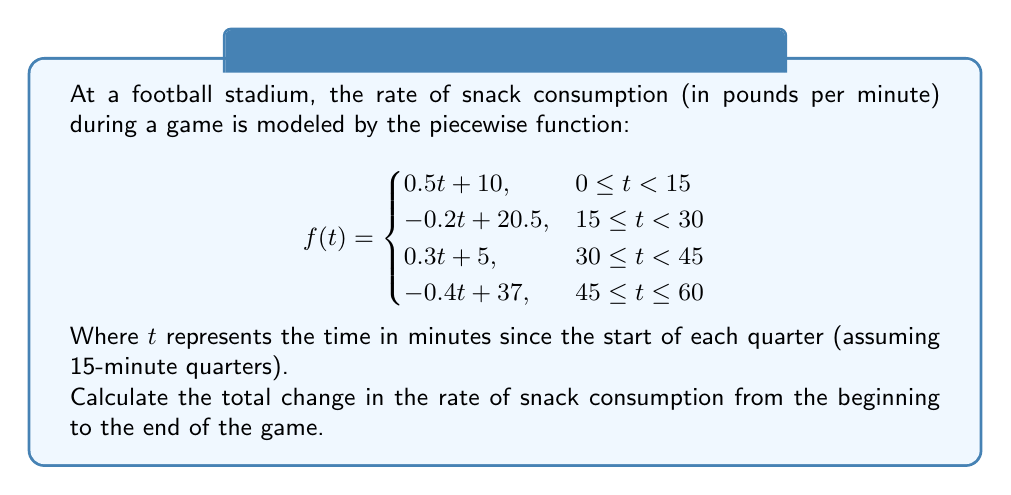What is the answer to this math problem? To solve this problem, we need to find the difference between the rate of snack consumption at the beginning and end of the game. Let's break it down step by step:

1) At the beginning of the game (t = 0 in the first quarter):
   $$f(0) = 0.5(0) + 10 = 10$$
   The initial rate is 10 pounds per minute.

2) At the end of the game (t = 60, which is t = 15 in the fourth quarter):
   $$f(15) = -0.4(15) + 37 = -6 + 37 = 31$$
   The final rate is 31 pounds per minute.

3) To calculate the total change, we subtract the initial rate from the final rate:
   $$\text{Total change} = 31 - 10 = 21$$

Therefore, the total change in the rate of snack consumption from the beginning to the end of the game is an increase of 21 pounds per minute.

Note: This problem demonstrates how to analyze rates of change using piecewise functions, which is a key concept in function transformations and analysis.
Answer: The total change in the rate of snack consumption from the beginning to the end of the game is an increase of 21 pounds per minute. 